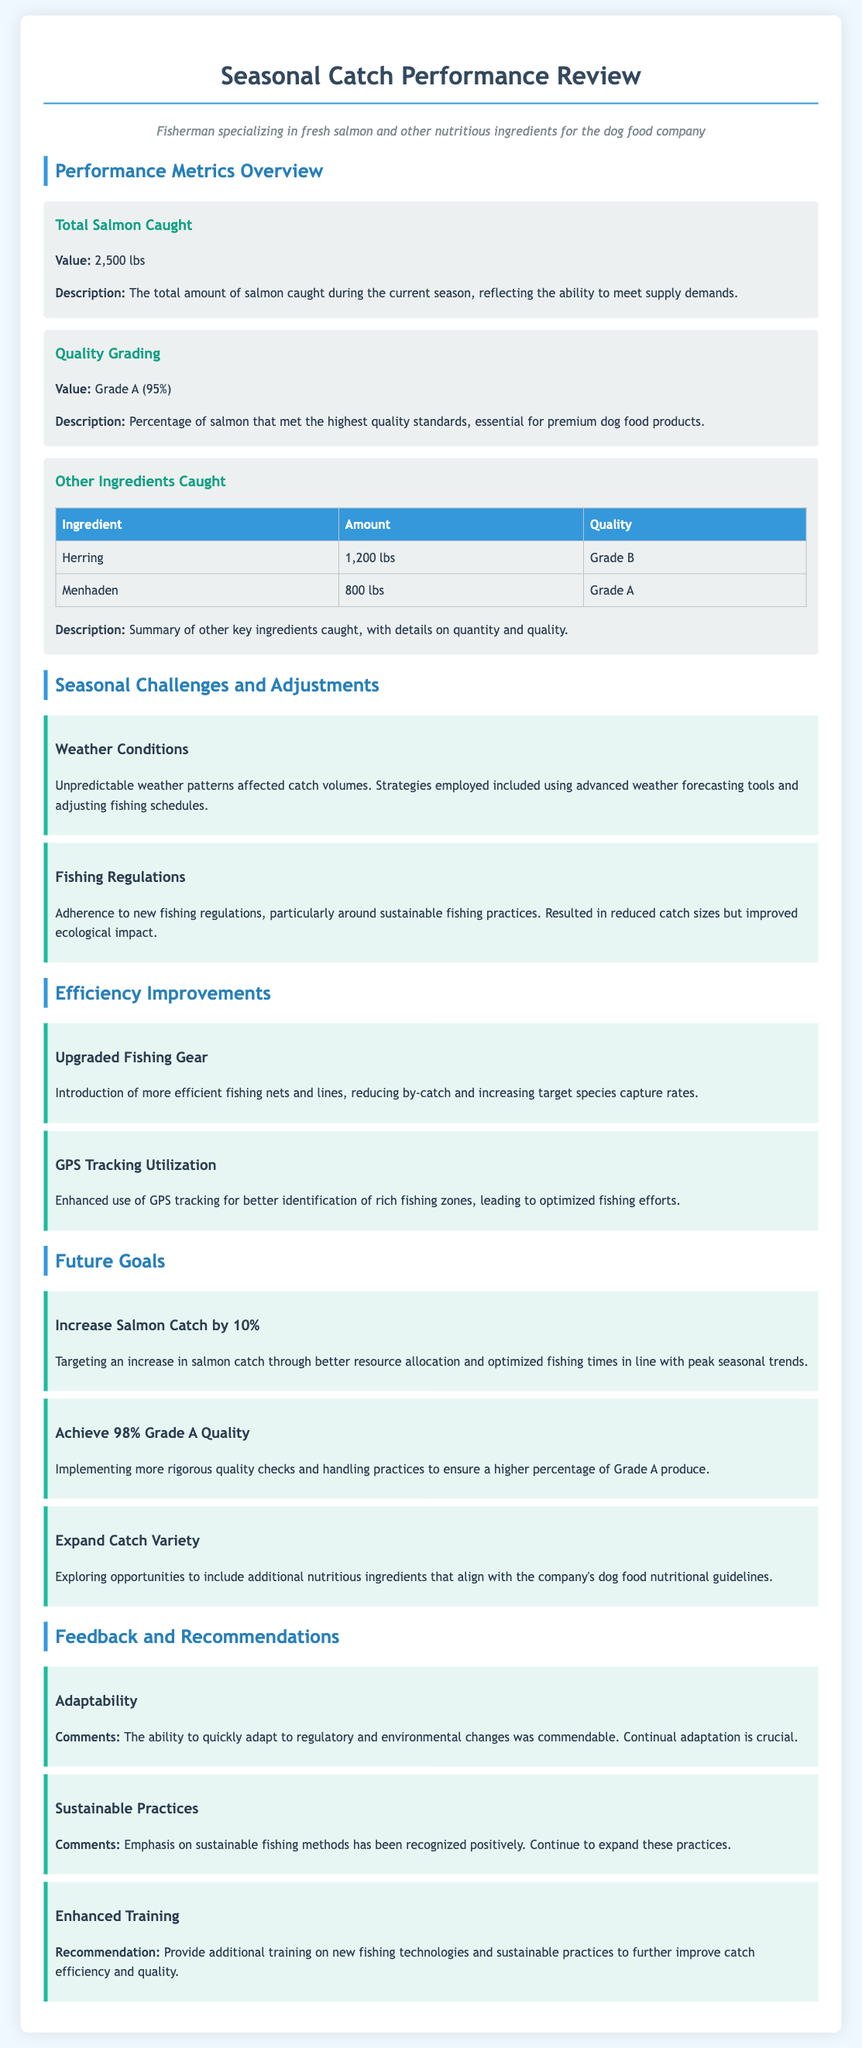What is the total amount of salmon caught? The total amount of salmon caught during the current season is specified in the document.
Answer: 2,500 lbs What is the quality grade percentage of salmon? The quality grading value indicates the percentage of salmon that met the highest quality standards.
Answer: 95% What are the other ingredients mentioned in the document? The document lists additional key ingredients caught along with their amounts and quality grades.
Answer: Herring, Menhaden What is the amount of herring caught? The document provides specific details on the amount of herring caught during the season.
Answer: 1,200 lbs What is one of the challenges faced during the fishing season? The challenges section details specific issues encountered while fishing, highlighting various circumstances affecting catch volumes.
Answer: Weather Conditions What percentage of Grade A quality is the goal for future catches? The future goals include a target for achieving a specific percentage of Grade A quality.
Answer: 98% What fishing technology was upgraded according to the efficiency improvements? The improvements section indicates specific enhancements made to fishing technology to increase efficiency.
Answer: Fishing nets and lines What does the feedback suggest regarding sustainable practices? The feedback section contains recommendations and observations regarding current fishing methods and their ecological impacts.
Answer: Expand these practices 